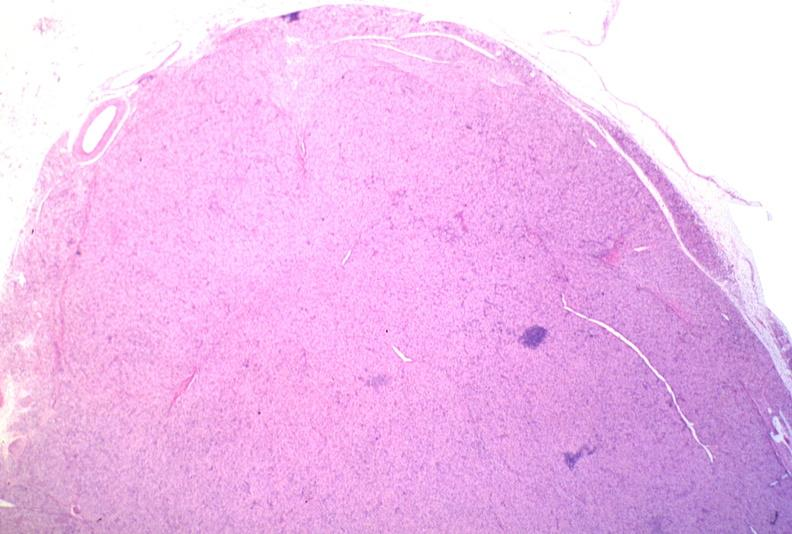does this image show lymph node, mycobacterium avium-intracellulae mai?
Answer the question using a single word or phrase. Yes 